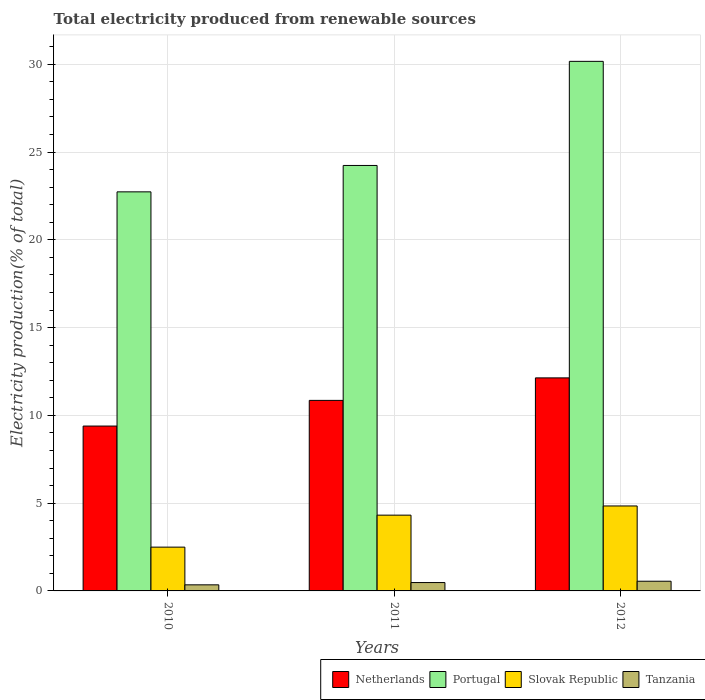How many different coloured bars are there?
Offer a terse response. 4. How many groups of bars are there?
Offer a terse response. 3. Are the number of bars per tick equal to the number of legend labels?
Make the answer very short. Yes. Are the number of bars on each tick of the X-axis equal?
Offer a very short reply. Yes. How many bars are there on the 3rd tick from the left?
Make the answer very short. 4. In how many cases, is the number of bars for a given year not equal to the number of legend labels?
Your answer should be compact. 0. What is the total electricity produced in Slovak Republic in 2012?
Your answer should be compact. 4.84. Across all years, what is the maximum total electricity produced in Slovak Republic?
Offer a terse response. 4.84. Across all years, what is the minimum total electricity produced in Netherlands?
Keep it short and to the point. 9.39. In which year was the total electricity produced in Portugal maximum?
Offer a very short reply. 2012. In which year was the total electricity produced in Slovak Republic minimum?
Provide a succinct answer. 2010. What is the total total electricity produced in Tanzania in the graph?
Provide a succinct answer. 1.38. What is the difference between the total electricity produced in Tanzania in 2011 and that in 2012?
Make the answer very short. -0.08. What is the difference between the total electricity produced in Netherlands in 2010 and the total electricity produced in Tanzania in 2012?
Your answer should be compact. 8.84. What is the average total electricity produced in Tanzania per year?
Provide a succinct answer. 0.46. In the year 2010, what is the difference between the total electricity produced in Slovak Republic and total electricity produced in Netherlands?
Keep it short and to the point. -6.9. What is the ratio of the total electricity produced in Slovak Republic in 2010 to that in 2012?
Offer a very short reply. 0.52. Is the total electricity produced in Tanzania in 2010 less than that in 2011?
Make the answer very short. Yes. What is the difference between the highest and the second highest total electricity produced in Netherlands?
Give a very brief answer. 1.28. What is the difference between the highest and the lowest total electricity produced in Slovak Republic?
Your answer should be compact. 2.35. Is the sum of the total electricity produced in Slovak Republic in 2010 and 2011 greater than the maximum total electricity produced in Tanzania across all years?
Offer a very short reply. Yes. What does the 1st bar from the left in 2012 represents?
Provide a short and direct response. Netherlands. How many bars are there?
Provide a short and direct response. 12. How many years are there in the graph?
Offer a very short reply. 3. Does the graph contain any zero values?
Offer a very short reply. No. Does the graph contain grids?
Your answer should be compact. Yes. How many legend labels are there?
Give a very brief answer. 4. How are the legend labels stacked?
Your answer should be very brief. Horizontal. What is the title of the graph?
Make the answer very short. Total electricity produced from renewable sources. Does "St. Martin (French part)" appear as one of the legend labels in the graph?
Keep it short and to the point. No. What is the label or title of the Y-axis?
Ensure brevity in your answer.  Electricity production(% of total). What is the Electricity production(% of total) of Netherlands in 2010?
Provide a succinct answer. 9.39. What is the Electricity production(% of total) in Portugal in 2010?
Make the answer very short. 22.73. What is the Electricity production(% of total) in Slovak Republic in 2010?
Offer a very short reply. 2.49. What is the Electricity production(% of total) in Tanzania in 2010?
Your response must be concise. 0.35. What is the Electricity production(% of total) in Netherlands in 2011?
Offer a very short reply. 10.85. What is the Electricity production(% of total) in Portugal in 2011?
Make the answer very short. 24.23. What is the Electricity production(% of total) in Slovak Republic in 2011?
Ensure brevity in your answer.  4.32. What is the Electricity production(% of total) of Tanzania in 2011?
Your response must be concise. 0.48. What is the Electricity production(% of total) in Netherlands in 2012?
Provide a succinct answer. 12.14. What is the Electricity production(% of total) of Portugal in 2012?
Your answer should be very brief. 30.16. What is the Electricity production(% of total) of Slovak Republic in 2012?
Your answer should be compact. 4.84. What is the Electricity production(% of total) in Tanzania in 2012?
Give a very brief answer. 0.55. Across all years, what is the maximum Electricity production(% of total) in Netherlands?
Offer a very short reply. 12.14. Across all years, what is the maximum Electricity production(% of total) of Portugal?
Give a very brief answer. 30.16. Across all years, what is the maximum Electricity production(% of total) of Slovak Republic?
Your response must be concise. 4.84. Across all years, what is the maximum Electricity production(% of total) in Tanzania?
Provide a succinct answer. 0.55. Across all years, what is the minimum Electricity production(% of total) in Netherlands?
Provide a succinct answer. 9.39. Across all years, what is the minimum Electricity production(% of total) in Portugal?
Provide a short and direct response. 22.73. Across all years, what is the minimum Electricity production(% of total) of Slovak Republic?
Give a very brief answer. 2.49. Across all years, what is the minimum Electricity production(% of total) of Tanzania?
Your response must be concise. 0.35. What is the total Electricity production(% of total) in Netherlands in the graph?
Offer a terse response. 32.38. What is the total Electricity production(% of total) in Portugal in the graph?
Offer a very short reply. 77.13. What is the total Electricity production(% of total) of Slovak Republic in the graph?
Offer a very short reply. 11.65. What is the total Electricity production(% of total) of Tanzania in the graph?
Keep it short and to the point. 1.38. What is the difference between the Electricity production(% of total) in Netherlands in 2010 and that in 2011?
Make the answer very short. -1.46. What is the difference between the Electricity production(% of total) of Portugal in 2010 and that in 2011?
Your response must be concise. -1.5. What is the difference between the Electricity production(% of total) of Slovak Republic in 2010 and that in 2011?
Your response must be concise. -1.82. What is the difference between the Electricity production(% of total) in Tanzania in 2010 and that in 2011?
Provide a short and direct response. -0.13. What is the difference between the Electricity production(% of total) in Netherlands in 2010 and that in 2012?
Keep it short and to the point. -2.74. What is the difference between the Electricity production(% of total) in Portugal in 2010 and that in 2012?
Your response must be concise. -7.43. What is the difference between the Electricity production(% of total) of Slovak Republic in 2010 and that in 2012?
Your response must be concise. -2.35. What is the difference between the Electricity production(% of total) of Tanzania in 2010 and that in 2012?
Provide a short and direct response. -0.21. What is the difference between the Electricity production(% of total) of Netherlands in 2011 and that in 2012?
Make the answer very short. -1.28. What is the difference between the Electricity production(% of total) of Portugal in 2011 and that in 2012?
Ensure brevity in your answer.  -5.93. What is the difference between the Electricity production(% of total) of Slovak Republic in 2011 and that in 2012?
Provide a succinct answer. -0.52. What is the difference between the Electricity production(% of total) of Tanzania in 2011 and that in 2012?
Give a very brief answer. -0.08. What is the difference between the Electricity production(% of total) of Netherlands in 2010 and the Electricity production(% of total) of Portugal in 2011?
Make the answer very short. -14.84. What is the difference between the Electricity production(% of total) of Netherlands in 2010 and the Electricity production(% of total) of Slovak Republic in 2011?
Ensure brevity in your answer.  5.08. What is the difference between the Electricity production(% of total) in Netherlands in 2010 and the Electricity production(% of total) in Tanzania in 2011?
Make the answer very short. 8.91. What is the difference between the Electricity production(% of total) of Portugal in 2010 and the Electricity production(% of total) of Slovak Republic in 2011?
Provide a succinct answer. 18.42. What is the difference between the Electricity production(% of total) of Portugal in 2010 and the Electricity production(% of total) of Tanzania in 2011?
Offer a very short reply. 22.26. What is the difference between the Electricity production(% of total) of Slovak Republic in 2010 and the Electricity production(% of total) of Tanzania in 2011?
Ensure brevity in your answer.  2.02. What is the difference between the Electricity production(% of total) in Netherlands in 2010 and the Electricity production(% of total) in Portugal in 2012?
Keep it short and to the point. -20.77. What is the difference between the Electricity production(% of total) in Netherlands in 2010 and the Electricity production(% of total) in Slovak Republic in 2012?
Provide a short and direct response. 4.55. What is the difference between the Electricity production(% of total) in Netherlands in 2010 and the Electricity production(% of total) in Tanzania in 2012?
Ensure brevity in your answer.  8.84. What is the difference between the Electricity production(% of total) of Portugal in 2010 and the Electricity production(% of total) of Slovak Republic in 2012?
Offer a very short reply. 17.89. What is the difference between the Electricity production(% of total) in Portugal in 2010 and the Electricity production(% of total) in Tanzania in 2012?
Your answer should be compact. 22.18. What is the difference between the Electricity production(% of total) of Slovak Republic in 2010 and the Electricity production(% of total) of Tanzania in 2012?
Your answer should be very brief. 1.94. What is the difference between the Electricity production(% of total) in Netherlands in 2011 and the Electricity production(% of total) in Portugal in 2012?
Provide a short and direct response. -19.31. What is the difference between the Electricity production(% of total) in Netherlands in 2011 and the Electricity production(% of total) in Slovak Republic in 2012?
Make the answer very short. 6.01. What is the difference between the Electricity production(% of total) of Netherlands in 2011 and the Electricity production(% of total) of Tanzania in 2012?
Ensure brevity in your answer.  10.3. What is the difference between the Electricity production(% of total) of Portugal in 2011 and the Electricity production(% of total) of Slovak Republic in 2012?
Your answer should be very brief. 19.4. What is the difference between the Electricity production(% of total) of Portugal in 2011 and the Electricity production(% of total) of Tanzania in 2012?
Offer a very short reply. 23.68. What is the difference between the Electricity production(% of total) in Slovak Republic in 2011 and the Electricity production(% of total) in Tanzania in 2012?
Make the answer very short. 3.76. What is the average Electricity production(% of total) of Netherlands per year?
Your response must be concise. 10.79. What is the average Electricity production(% of total) in Portugal per year?
Your answer should be very brief. 25.71. What is the average Electricity production(% of total) of Slovak Republic per year?
Provide a short and direct response. 3.88. What is the average Electricity production(% of total) in Tanzania per year?
Give a very brief answer. 0.46. In the year 2010, what is the difference between the Electricity production(% of total) of Netherlands and Electricity production(% of total) of Portugal?
Your answer should be very brief. -13.34. In the year 2010, what is the difference between the Electricity production(% of total) in Netherlands and Electricity production(% of total) in Slovak Republic?
Give a very brief answer. 6.9. In the year 2010, what is the difference between the Electricity production(% of total) in Netherlands and Electricity production(% of total) in Tanzania?
Your answer should be very brief. 9.04. In the year 2010, what is the difference between the Electricity production(% of total) in Portugal and Electricity production(% of total) in Slovak Republic?
Make the answer very short. 20.24. In the year 2010, what is the difference between the Electricity production(% of total) in Portugal and Electricity production(% of total) in Tanzania?
Offer a very short reply. 22.38. In the year 2010, what is the difference between the Electricity production(% of total) of Slovak Republic and Electricity production(% of total) of Tanzania?
Provide a short and direct response. 2.15. In the year 2011, what is the difference between the Electricity production(% of total) in Netherlands and Electricity production(% of total) in Portugal?
Offer a terse response. -13.38. In the year 2011, what is the difference between the Electricity production(% of total) in Netherlands and Electricity production(% of total) in Slovak Republic?
Keep it short and to the point. 6.54. In the year 2011, what is the difference between the Electricity production(% of total) of Netherlands and Electricity production(% of total) of Tanzania?
Keep it short and to the point. 10.38. In the year 2011, what is the difference between the Electricity production(% of total) in Portugal and Electricity production(% of total) in Slovak Republic?
Provide a succinct answer. 19.92. In the year 2011, what is the difference between the Electricity production(% of total) of Portugal and Electricity production(% of total) of Tanzania?
Provide a succinct answer. 23.76. In the year 2011, what is the difference between the Electricity production(% of total) in Slovak Republic and Electricity production(% of total) in Tanzania?
Provide a short and direct response. 3.84. In the year 2012, what is the difference between the Electricity production(% of total) in Netherlands and Electricity production(% of total) in Portugal?
Keep it short and to the point. -18.03. In the year 2012, what is the difference between the Electricity production(% of total) of Netherlands and Electricity production(% of total) of Slovak Republic?
Make the answer very short. 7.3. In the year 2012, what is the difference between the Electricity production(% of total) in Netherlands and Electricity production(% of total) in Tanzania?
Provide a succinct answer. 11.58. In the year 2012, what is the difference between the Electricity production(% of total) of Portugal and Electricity production(% of total) of Slovak Republic?
Offer a very short reply. 25.33. In the year 2012, what is the difference between the Electricity production(% of total) in Portugal and Electricity production(% of total) in Tanzania?
Your answer should be very brief. 29.61. In the year 2012, what is the difference between the Electricity production(% of total) in Slovak Republic and Electricity production(% of total) in Tanzania?
Your answer should be very brief. 4.29. What is the ratio of the Electricity production(% of total) of Netherlands in 2010 to that in 2011?
Keep it short and to the point. 0.87. What is the ratio of the Electricity production(% of total) in Portugal in 2010 to that in 2011?
Your answer should be very brief. 0.94. What is the ratio of the Electricity production(% of total) in Slovak Republic in 2010 to that in 2011?
Provide a short and direct response. 0.58. What is the ratio of the Electricity production(% of total) of Tanzania in 2010 to that in 2011?
Ensure brevity in your answer.  0.73. What is the ratio of the Electricity production(% of total) of Netherlands in 2010 to that in 2012?
Your answer should be compact. 0.77. What is the ratio of the Electricity production(% of total) in Portugal in 2010 to that in 2012?
Offer a terse response. 0.75. What is the ratio of the Electricity production(% of total) of Slovak Republic in 2010 to that in 2012?
Give a very brief answer. 0.52. What is the ratio of the Electricity production(% of total) of Tanzania in 2010 to that in 2012?
Give a very brief answer. 0.63. What is the ratio of the Electricity production(% of total) in Netherlands in 2011 to that in 2012?
Give a very brief answer. 0.89. What is the ratio of the Electricity production(% of total) of Portugal in 2011 to that in 2012?
Provide a short and direct response. 0.8. What is the ratio of the Electricity production(% of total) in Slovak Republic in 2011 to that in 2012?
Give a very brief answer. 0.89. What is the ratio of the Electricity production(% of total) of Tanzania in 2011 to that in 2012?
Offer a terse response. 0.86. What is the difference between the highest and the second highest Electricity production(% of total) in Netherlands?
Make the answer very short. 1.28. What is the difference between the highest and the second highest Electricity production(% of total) in Portugal?
Offer a terse response. 5.93. What is the difference between the highest and the second highest Electricity production(% of total) in Slovak Republic?
Your response must be concise. 0.52. What is the difference between the highest and the second highest Electricity production(% of total) in Tanzania?
Offer a terse response. 0.08. What is the difference between the highest and the lowest Electricity production(% of total) in Netherlands?
Provide a short and direct response. 2.74. What is the difference between the highest and the lowest Electricity production(% of total) of Portugal?
Your response must be concise. 7.43. What is the difference between the highest and the lowest Electricity production(% of total) in Slovak Republic?
Provide a succinct answer. 2.35. What is the difference between the highest and the lowest Electricity production(% of total) in Tanzania?
Provide a short and direct response. 0.21. 